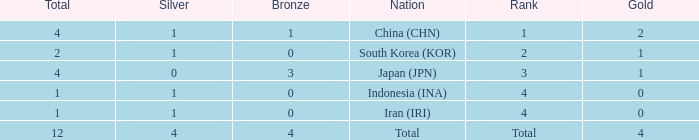Could you parse the entire table? {'header': ['Total', 'Silver', 'Bronze', 'Nation', 'Rank', 'Gold'], 'rows': [['4', '1', '1', 'China (CHN)', '1', '2'], ['2', '1', '0', 'South Korea (KOR)', '2', '1'], ['4', '0', '3', 'Japan (JPN)', '3', '1'], ['1', '1', '0', 'Indonesia (INA)', '4', '0'], ['1', '1', '0', 'Iran (IRI)', '4', '0'], ['12', '4', '4', 'Total', 'Total', '4']]} How many silver medals for the nation with fewer than 1 golds and total less than 1? 0.0. 